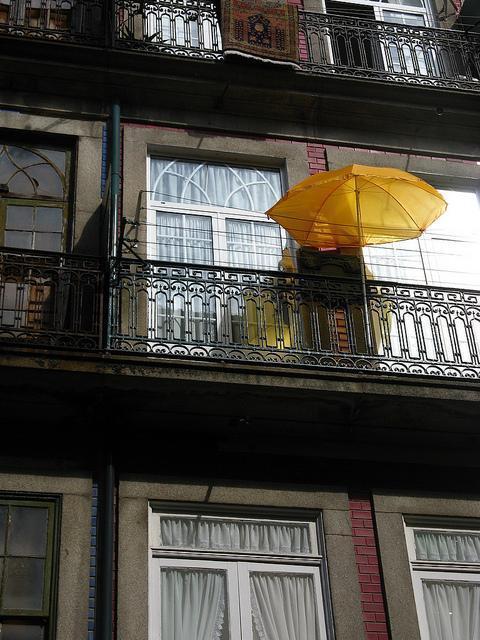How many stories up is the umbrella?
Give a very brief answer. 2. How many white airplanes do you see?
Give a very brief answer. 0. 